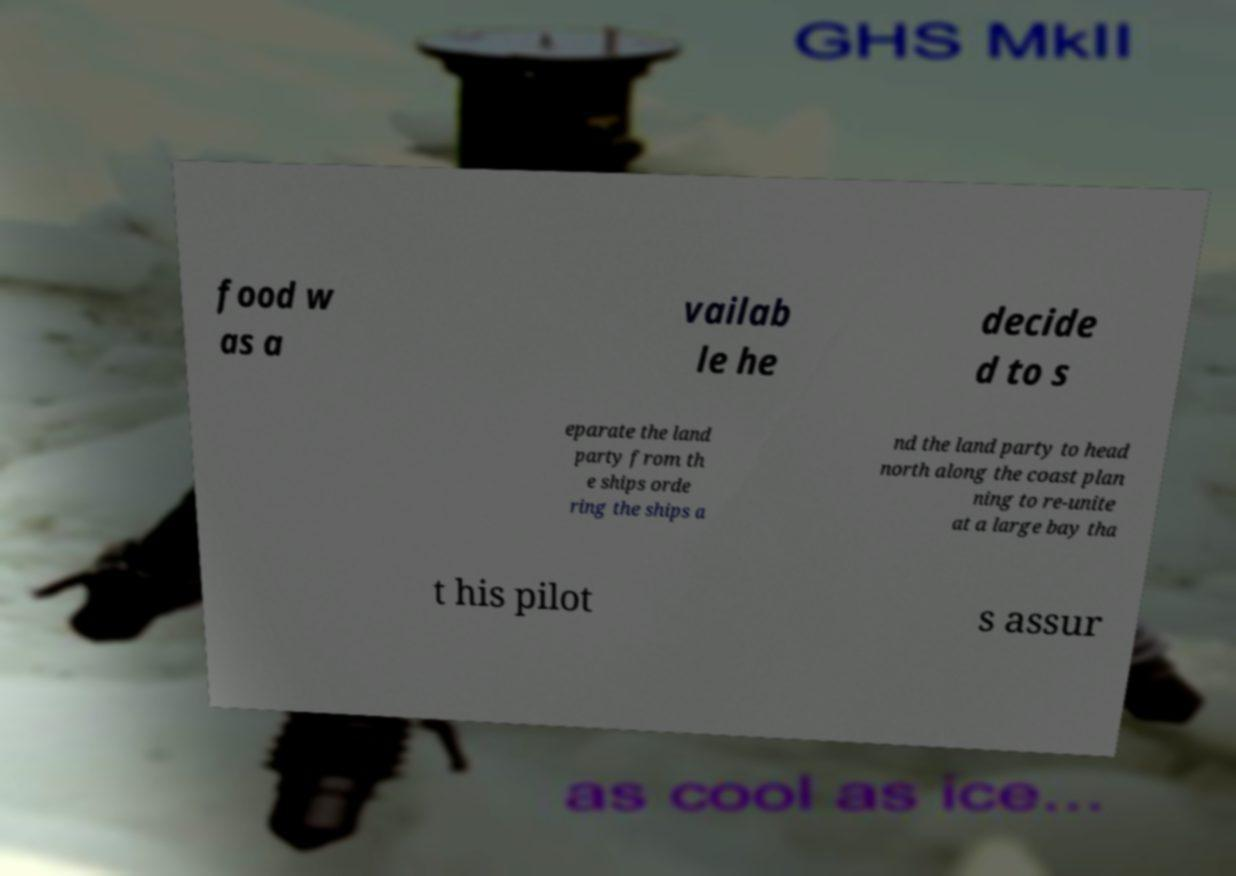For documentation purposes, I need the text within this image transcribed. Could you provide that? food w as a vailab le he decide d to s eparate the land party from th e ships orde ring the ships a nd the land party to head north along the coast plan ning to re-unite at a large bay tha t his pilot s assur 